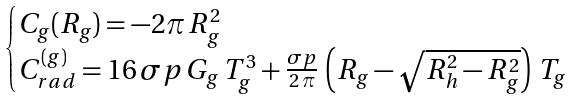Convert formula to latex. <formula><loc_0><loc_0><loc_500><loc_500>\begin{cases} C _ { g } ( R _ { g } ) = - 2 \pi \, R _ { g } ^ { 2 } \\ C _ { r a d } ^ { ( g ) } = 1 6 \, \sigma p \, G _ { g } \, T _ { g } ^ { 3 } + \frac { \sigma p } { 2 \, \pi } \, \left ( R _ { g } - \sqrt { R _ { h } ^ { 2 } - R _ { g } ^ { 2 } } \right ) \, T _ { g } \end{cases}</formula> 